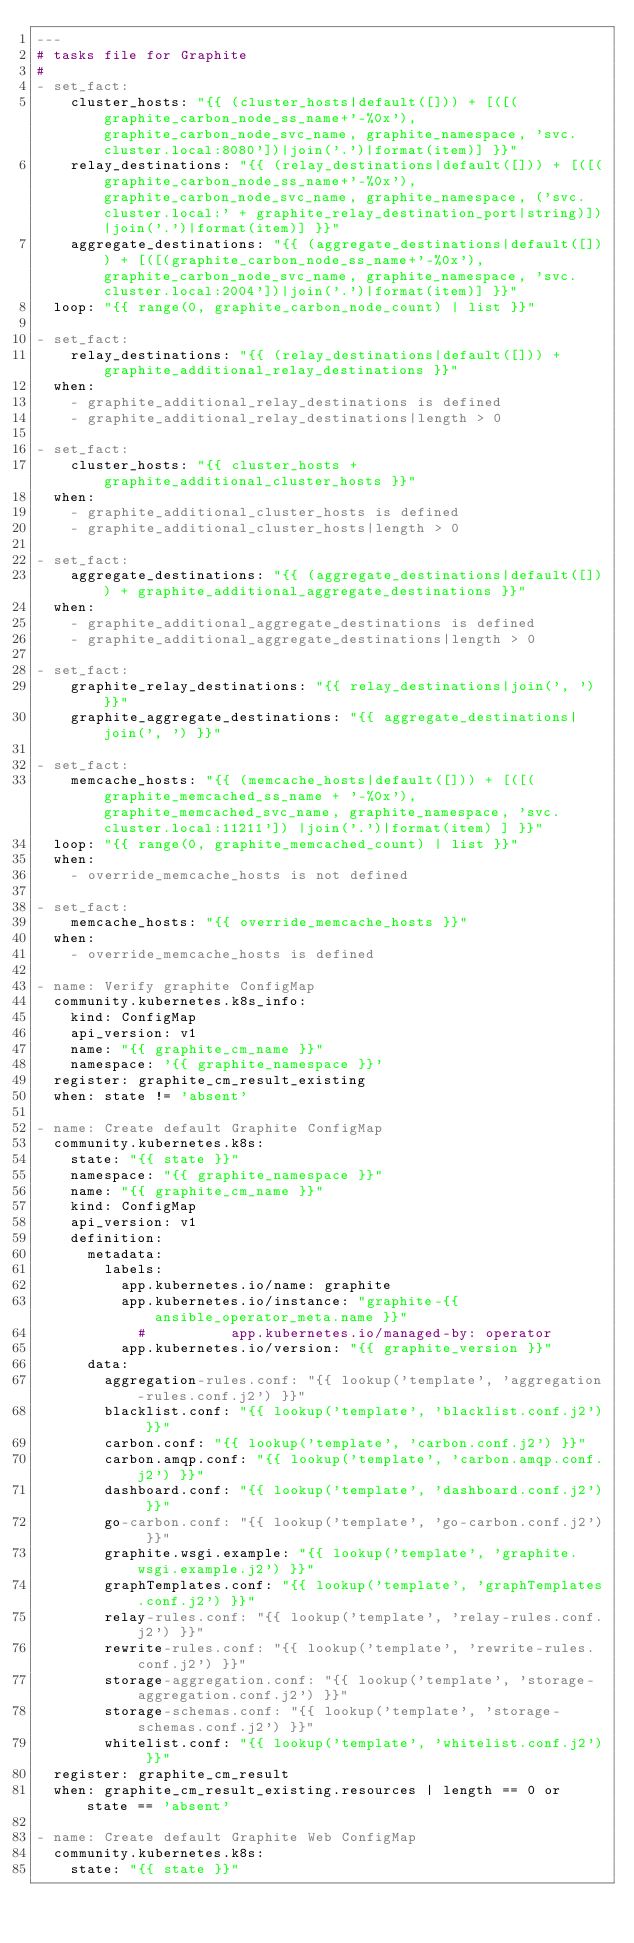<code> <loc_0><loc_0><loc_500><loc_500><_YAML_>---
# tasks file for Graphite
#
- set_fact:
    cluster_hosts: "{{ (cluster_hosts|default([])) + [([(graphite_carbon_node_ss_name+'-%0x'), graphite_carbon_node_svc_name, graphite_namespace, 'svc.cluster.local:8080'])|join('.')|format(item)] }}"
    relay_destinations: "{{ (relay_destinations|default([])) + [([(graphite_carbon_node_ss_name+'-%0x'), graphite_carbon_node_svc_name, graphite_namespace, ('svc.cluster.local:' + graphite_relay_destination_port|string)])|join('.')|format(item)] }}"
    aggregate_destinations: "{{ (aggregate_destinations|default([])) + [([(graphite_carbon_node_ss_name+'-%0x'), graphite_carbon_node_svc_name, graphite_namespace, 'svc.cluster.local:2004'])|join('.')|format(item)] }}"
  loop: "{{ range(0, graphite_carbon_node_count) | list }}"

- set_fact:
    relay_destinations: "{{ (relay_destinations|default([])) + graphite_additional_relay_destinations }}"
  when: 
    - graphite_additional_relay_destinations is defined 
    - graphite_additional_relay_destinations|length > 0

- set_fact:
    cluster_hosts: "{{ cluster_hosts + graphite_additional_cluster_hosts }}"
  when:
    - graphite_additional_cluster_hosts is defined
    - graphite_additional_cluster_hosts|length > 0

- set_fact:
    aggregate_destinations: "{{ (aggregate_destinations|default([])) + graphite_additional_aggregate_destinations }}"
  when: 
    - graphite_additional_aggregate_destinations is defined 
    - graphite_additional_aggregate_destinations|length > 0

- set_fact:
    graphite_relay_destinations: "{{ relay_destinations|join(', ') }}"
    graphite_aggregate_destinations: "{{ aggregate_destinations|join(', ') }}"

- set_fact:
    memcache_hosts: "{{ (memcache_hosts|default([])) + [([(graphite_memcached_ss_name + '-%0x'), graphite_memcached_svc_name, graphite_namespace, 'svc.cluster.local:11211']) |join('.')|format(item) ] }}"
  loop: "{{ range(0, graphite_memcached_count) | list }}"
  when:
    - override_memcache_hosts is not defined

- set_fact:
    memcache_hosts: "{{ override_memcache_hosts }}"
  when:
    - override_memcache_hosts is defined

- name: Verify graphite ConfigMap
  community.kubernetes.k8s_info:
    kind: ConfigMap
    api_version: v1
    name: "{{ graphite_cm_name }}"
    namespace: '{{ graphite_namespace }}'
  register: graphite_cm_result_existing
  when: state != 'absent'

- name: Create default Graphite ConfigMap
  community.kubernetes.k8s:
    state: "{{ state }}"
    namespace: "{{ graphite_namespace }}"
    name: "{{ graphite_cm_name }}"
    kind: ConfigMap
    api_version: v1
    definition: 
      metadata:
        labels:
          app.kubernetes.io/name: graphite
          app.kubernetes.io/instance: "graphite-{{ansible_operator_meta.name }}"
            #          app.kubernetes.io/managed-by: operator
          app.kubernetes.io/version: "{{ graphite_version }}"
      data:
        aggregation-rules.conf: "{{ lookup('template', 'aggregation-rules.conf.j2') }}"
        blacklist.conf: "{{ lookup('template', 'blacklist.conf.j2') }}"
        carbon.conf: "{{ lookup('template', 'carbon.conf.j2') }}"
        carbon.amqp.conf: "{{ lookup('template', 'carbon.amqp.conf.j2') }}"
        dashboard.conf: "{{ lookup('template', 'dashboard.conf.j2') }}"
        go-carbon.conf: "{{ lookup('template', 'go-carbon.conf.j2') }}"
        graphite.wsgi.example: "{{ lookup('template', 'graphite.wsgi.example.j2') }}"
        graphTemplates.conf: "{{ lookup('template', 'graphTemplates.conf.j2') }}"
        relay-rules.conf: "{{ lookup('template', 'relay-rules.conf.j2') }}"
        rewrite-rules.conf: "{{ lookup('template', 'rewrite-rules.conf.j2') }}"
        storage-aggregation.conf: "{{ lookup('template', 'storage-aggregation.conf.j2') }}"
        storage-schemas.conf: "{{ lookup('template', 'storage-schemas.conf.j2') }}"
        whitelist.conf: "{{ lookup('template', 'whitelist.conf.j2') }}"
  register: graphite_cm_result
  when: graphite_cm_result_existing.resources | length == 0 or state == 'absent'

- name: Create default Graphite Web ConfigMap
  community.kubernetes.k8s:
    state: "{{ state }}"</code> 